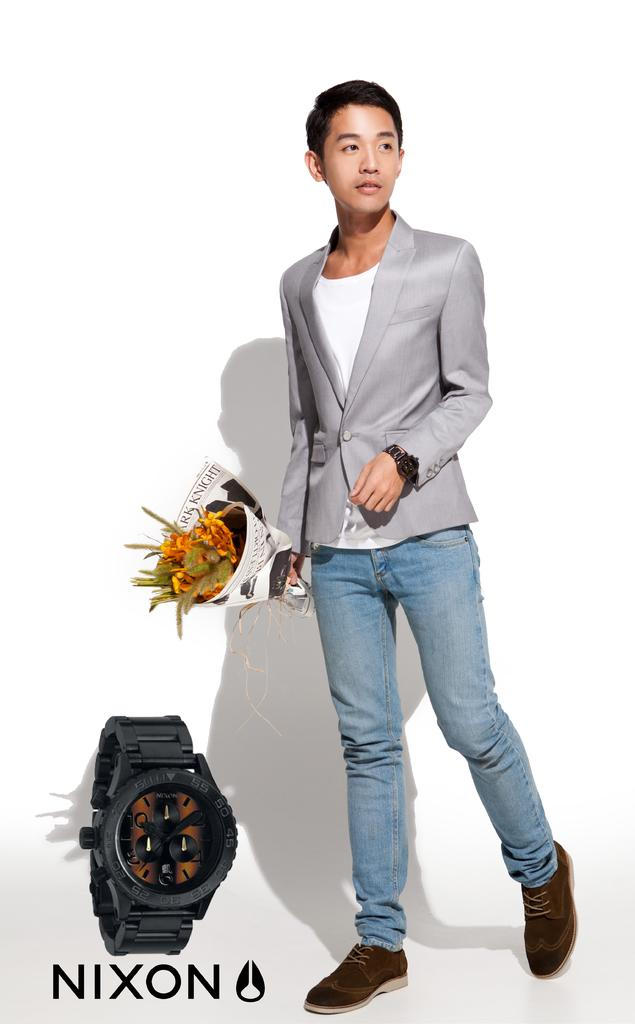<image>
Offer a succinct explanation of the picture presented. An ad for a Nixon watch has a man with flowers wearing the watch. 